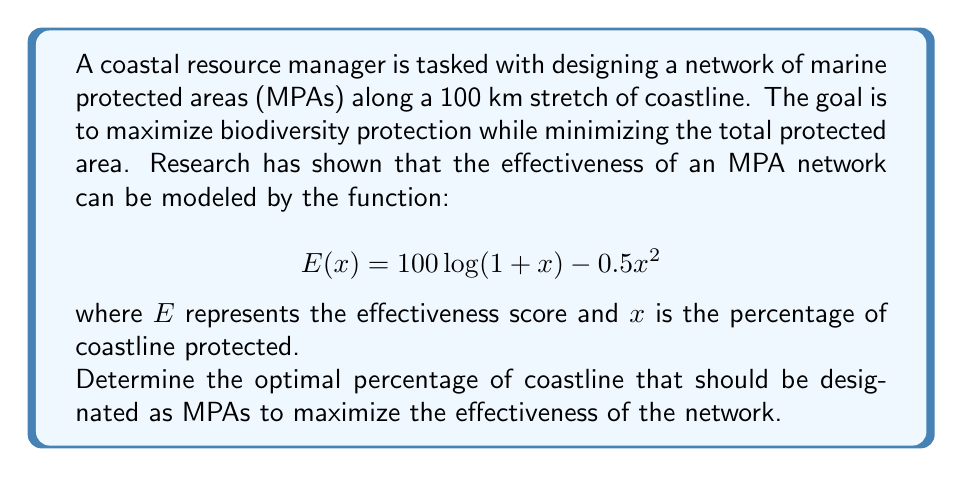Solve this math problem. To solve this optimization problem, we need to find the maximum value of the effectiveness function $E(x)$. This can be done by finding the point where the derivative of $E(x)$ equals zero.

1. First, let's find the derivative of $E(x)$:

   $$E'(x) = \frac{d}{dx}[100\log(1+x) - 0.5x^2]$$
   $$E'(x) = \frac{100}{1+x} - x$$

2. Now, set the derivative equal to zero and solve for x:

   $$\frac{100}{1+x} - x = 0$$
   $$100 = x + x^2$$
   $$x^2 + x - 100 = 0$$

3. This is a quadratic equation. We can solve it using the quadratic formula:

   $$x = \frac{-b \pm \sqrt{b^2 - 4ac}}{2a}$$

   where $a=1$, $b=1$, and $c=-100$

4. Plugging in these values:

   $$x = \frac{-1 \pm \sqrt{1^2 - 4(1)(-100)}}{2(1)}$$
   $$x = \frac{-1 \pm \sqrt{401}}{2}$$

5. This gives us two solutions:

   $$x_1 = \frac{-1 + \sqrt{401}}{2} \approx 9.5122$$
   $$x_2 = \frac{-1 - \sqrt{401}}{2} \approx -10.5122$$

6. Since we're dealing with percentages, we can discard the negative solution. Therefore, the optimal percentage is approximately 9.5122%.

7. To confirm this is a maximum (not a minimum), we can check the second derivative:

   $$E''(x) = -\frac{100}{(1+x)^2} - 1$$

   At $x \approx 9.5122$, $E''(x)$ is negative, confirming this is indeed a maximum.
Answer: The optimal percentage of coastline that should be designated as MPAs is approximately 9.5122%. 